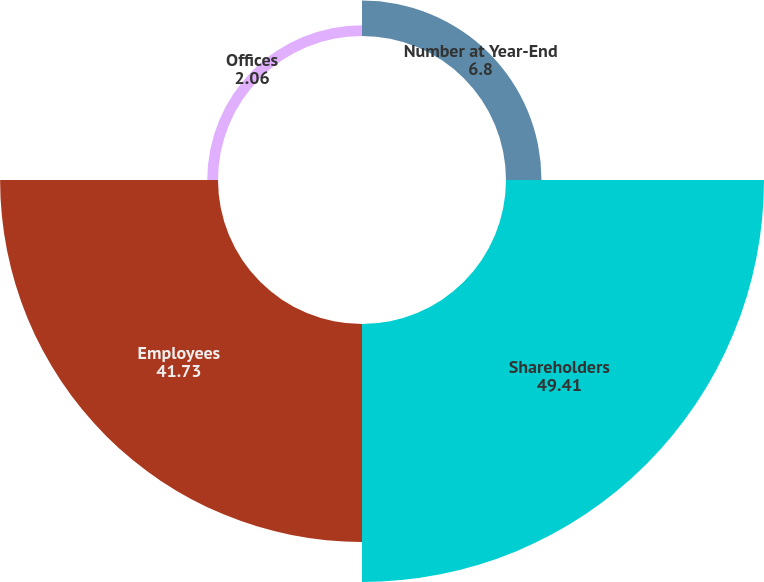Convert chart. <chart><loc_0><loc_0><loc_500><loc_500><pie_chart><fcel>Number at Year-End<fcel>Shareholders<fcel>Employees<fcel>Offices<nl><fcel>6.8%<fcel>49.41%<fcel>41.73%<fcel>2.06%<nl></chart> 